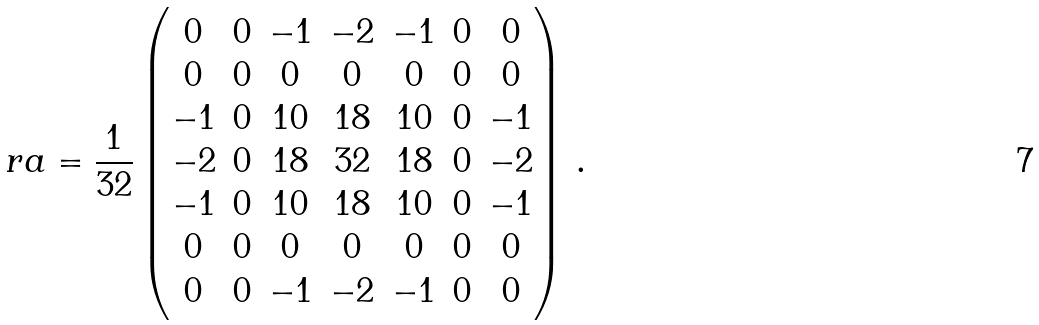<formula> <loc_0><loc_0><loc_500><loc_500>\ r a = \frac { 1 } { 3 2 } \left ( \begin{matrix} 0 & 0 & - 1 & - 2 & - 1 & 0 & 0 \\ 0 & 0 & 0 & 0 & 0 & 0 & 0 \\ - 1 & 0 & 1 0 & 1 8 & 1 0 & 0 & - 1 \\ - 2 & 0 & 1 8 & 3 2 & 1 8 & 0 & - 2 \\ - 1 & 0 & 1 0 & 1 8 & 1 0 & 0 & - 1 \\ 0 & 0 & 0 & 0 & 0 & 0 & 0 \\ { 0 } & 0 & - 1 & - 2 & - 1 & 0 & 0 \\ \end{matrix} \right ) \, .</formula> 